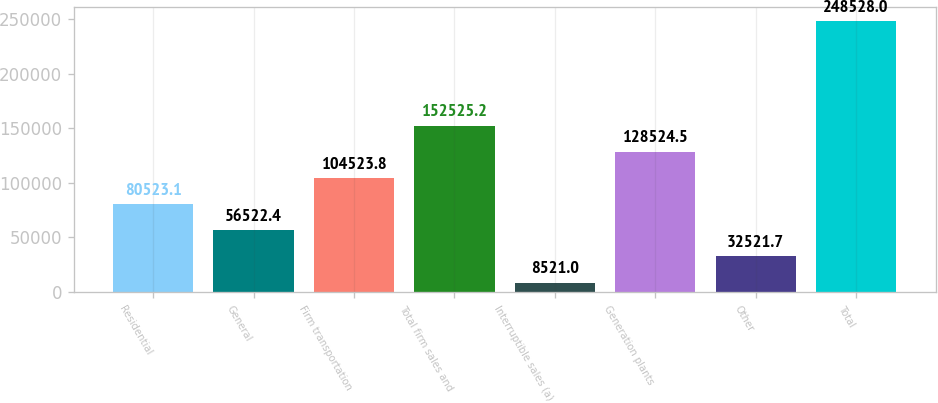<chart> <loc_0><loc_0><loc_500><loc_500><bar_chart><fcel>Residential<fcel>General<fcel>Firm transportation<fcel>Total firm sales and<fcel>Interruptible sales (a)<fcel>Generation plants<fcel>Other<fcel>Total<nl><fcel>80523.1<fcel>56522.4<fcel>104524<fcel>152525<fcel>8521<fcel>128524<fcel>32521.7<fcel>248528<nl></chart> 